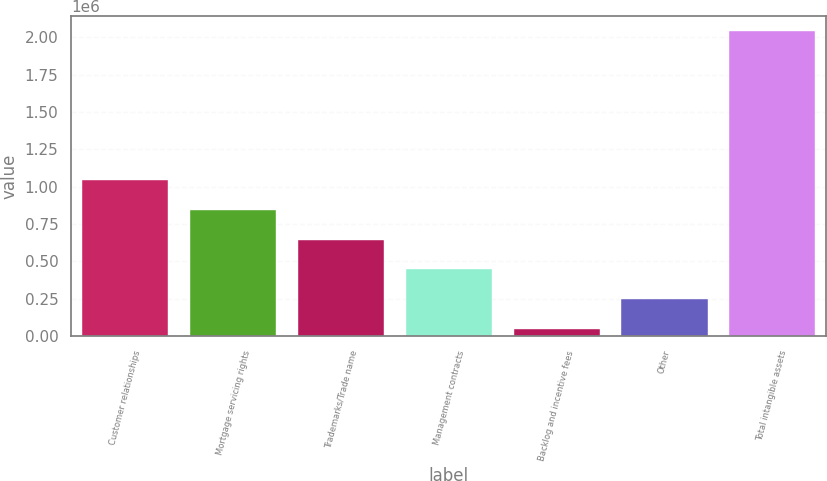Convert chart. <chart><loc_0><loc_0><loc_500><loc_500><bar_chart><fcel>Customer relationships<fcel>Mortgage servicing rights<fcel>Trademarks/Trade name<fcel>Management contracts<fcel>Backlog and incentive fees<fcel>Other<fcel>Total intangible assets<nl><fcel>1.04469e+06<fcel>845682<fcel>646678<fcel>447675<fcel>49667<fcel>248671<fcel>2.0397e+06<nl></chart> 